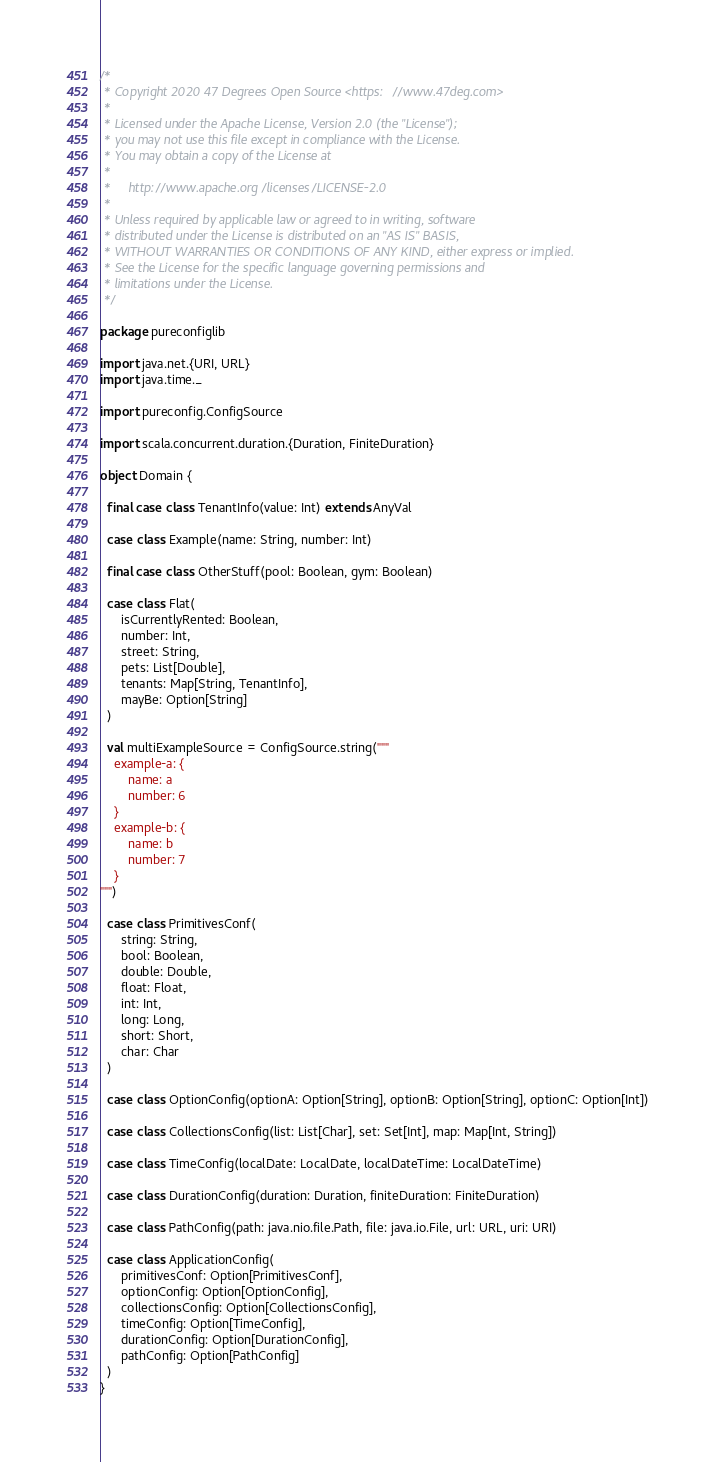<code> <loc_0><loc_0><loc_500><loc_500><_Scala_>/*
 * Copyright 2020 47 Degrees Open Source <https://www.47deg.com>
 *
 * Licensed under the Apache License, Version 2.0 (the "License");
 * you may not use this file except in compliance with the License.
 * You may obtain a copy of the License at
 *
 *     http://www.apache.org/licenses/LICENSE-2.0
 *
 * Unless required by applicable law or agreed to in writing, software
 * distributed under the License is distributed on an "AS IS" BASIS,
 * WITHOUT WARRANTIES OR CONDITIONS OF ANY KIND, either express or implied.
 * See the License for the specific language governing permissions and
 * limitations under the License.
 */

package pureconfiglib

import java.net.{URI, URL}
import java.time._

import pureconfig.ConfigSource

import scala.concurrent.duration.{Duration, FiniteDuration}

object Domain {

  final case class TenantInfo(value: Int) extends AnyVal

  case class Example(name: String, number: Int)

  final case class OtherStuff(pool: Boolean, gym: Boolean)

  case class Flat(
      isCurrentlyRented: Boolean,
      number: Int,
      street: String,
      pets: List[Double],
      tenants: Map[String, TenantInfo],
      mayBe: Option[String]
  )

  val multiExampleSource = ConfigSource.string("""
    example-a: {
        name: a
        number: 6
    }
    example-b: {
        name: b
        number: 7
    }
""")

  case class PrimitivesConf(
      string: String,
      bool: Boolean,
      double: Double,
      float: Float,
      int: Int,
      long: Long,
      short: Short,
      char: Char
  )

  case class OptionConfig(optionA: Option[String], optionB: Option[String], optionC: Option[Int])

  case class CollectionsConfig(list: List[Char], set: Set[Int], map: Map[Int, String])

  case class TimeConfig(localDate: LocalDate, localDateTime: LocalDateTime)

  case class DurationConfig(duration: Duration, finiteDuration: FiniteDuration)

  case class PathConfig(path: java.nio.file.Path, file: java.io.File, url: URL, uri: URI)

  case class ApplicationConfig(
      primitivesConf: Option[PrimitivesConf],
      optionConfig: Option[OptionConfig],
      collectionsConfig: Option[CollectionsConfig],
      timeConfig: Option[TimeConfig],
      durationConfig: Option[DurationConfig],
      pathConfig: Option[PathConfig]
  )
}
</code> 